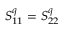Convert formula to latex. <formula><loc_0><loc_0><loc_500><loc_500>S _ { 1 1 } ^ { q } = S _ { 2 2 } ^ { q }</formula> 